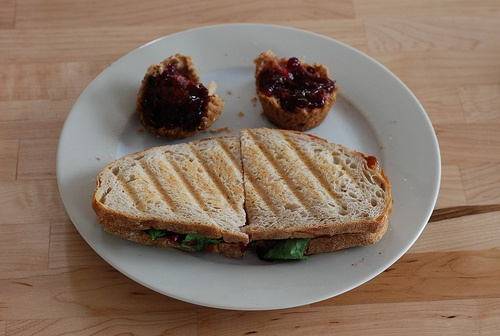Describe the objects in this image and their specific colors. I can see dining table in darkgray, gray, tan, and maroon tones and sandwich in gray, darkgray, tan, and maroon tones in this image. 